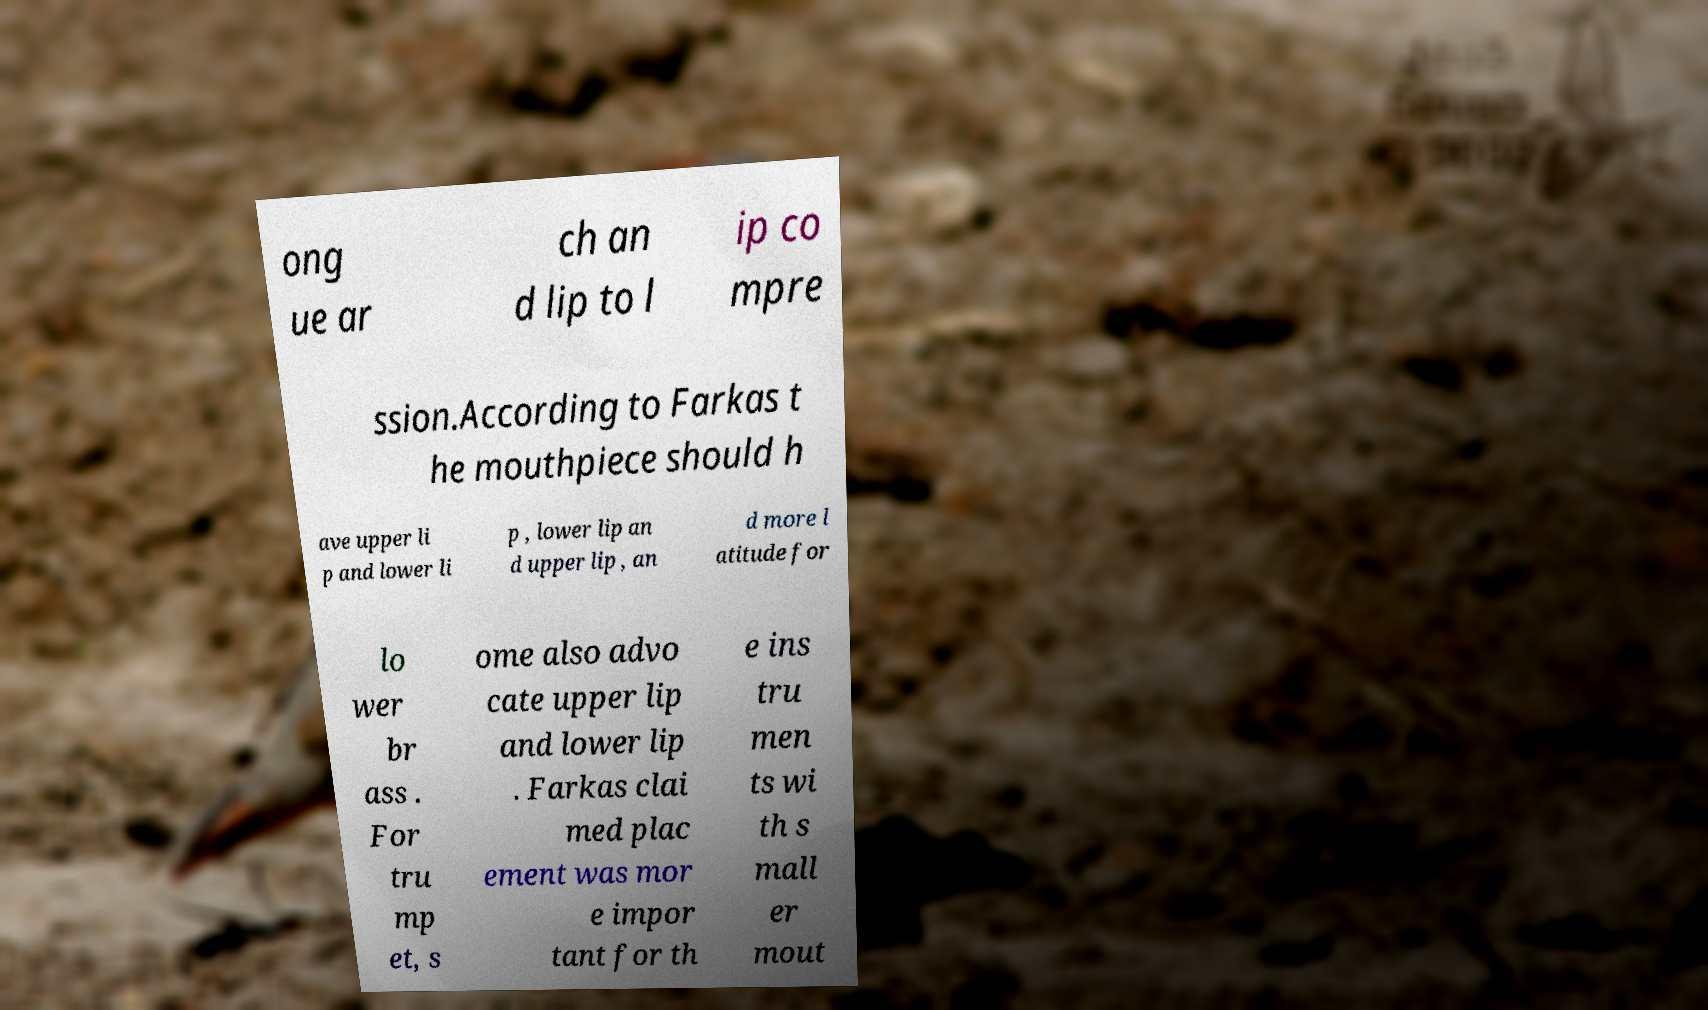Could you extract and type out the text from this image? ong ue ar ch an d lip to l ip co mpre ssion.According to Farkas t he mouthpiece should h ave upper li p and lower li p , lower lip an d upper lip , an d more l atitude for lo wer br ass . For tru mp et, s ome also advo cate upper lip and lower lip . Farkas clai med plac ement was mor e impor tant for th e ins tru men ts wi th s mall er mout 